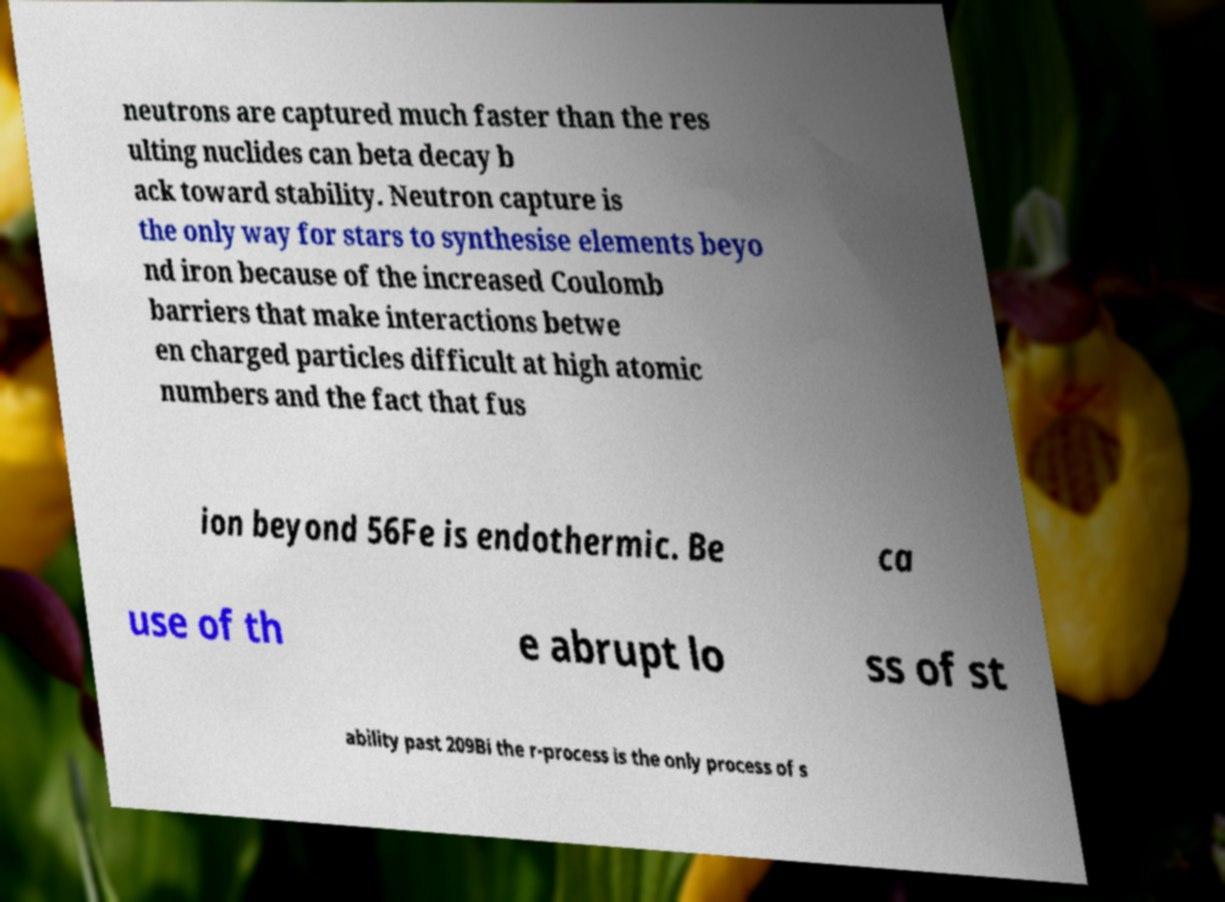There's text embedded in this image that I need extracted. Can you transcribe it verbatim? neutrons are captured much faster than the res ulting nuclides can beta decay b ack toward stability. Neutron capture is the only way for stars to synthesise elements beyo nd iron because of the increased Coulomb barriers that make interactions betwe en charged particles difficult at high atomic numbers and the fact that fus ion beyond 56Fe is endothermic. Be ca use of th e abrupt lo ss of st ability past 209Bi the r-process is the only process of s 